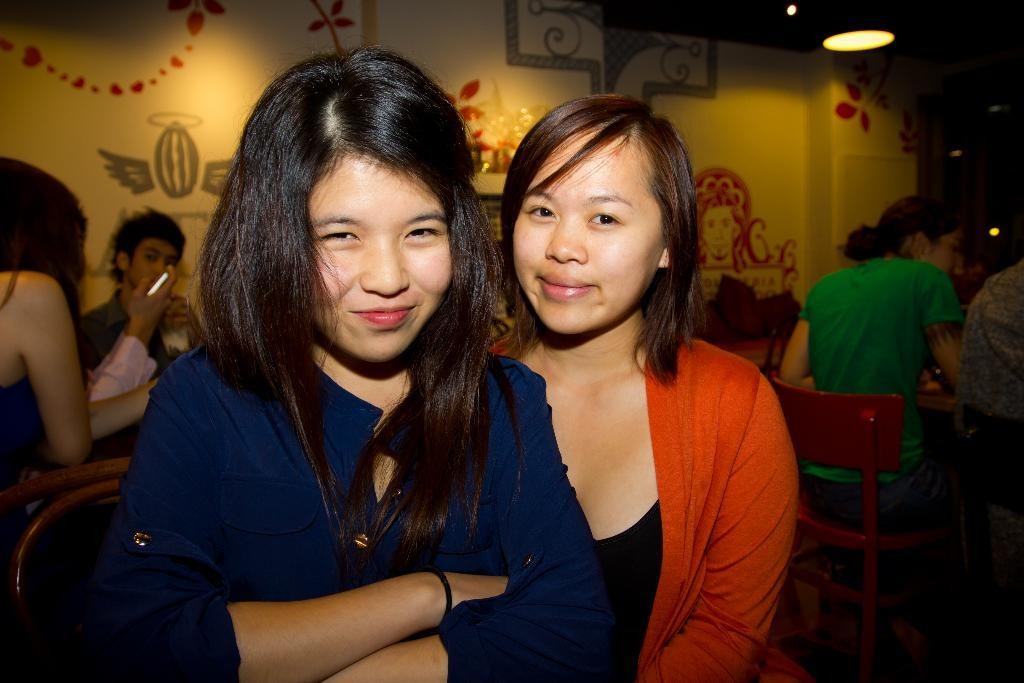Who or what is present in the image? There are people in the image. What type of furniture can be seen in the image? There is a chair in the image. What is the source of light in the image? There is a light visible at the top of the image. How many zebras are present in the image? There are no zebras present in the image. What is the neck size of the person in the image? The provided facts do not give information about the neck size of the person in the image. 